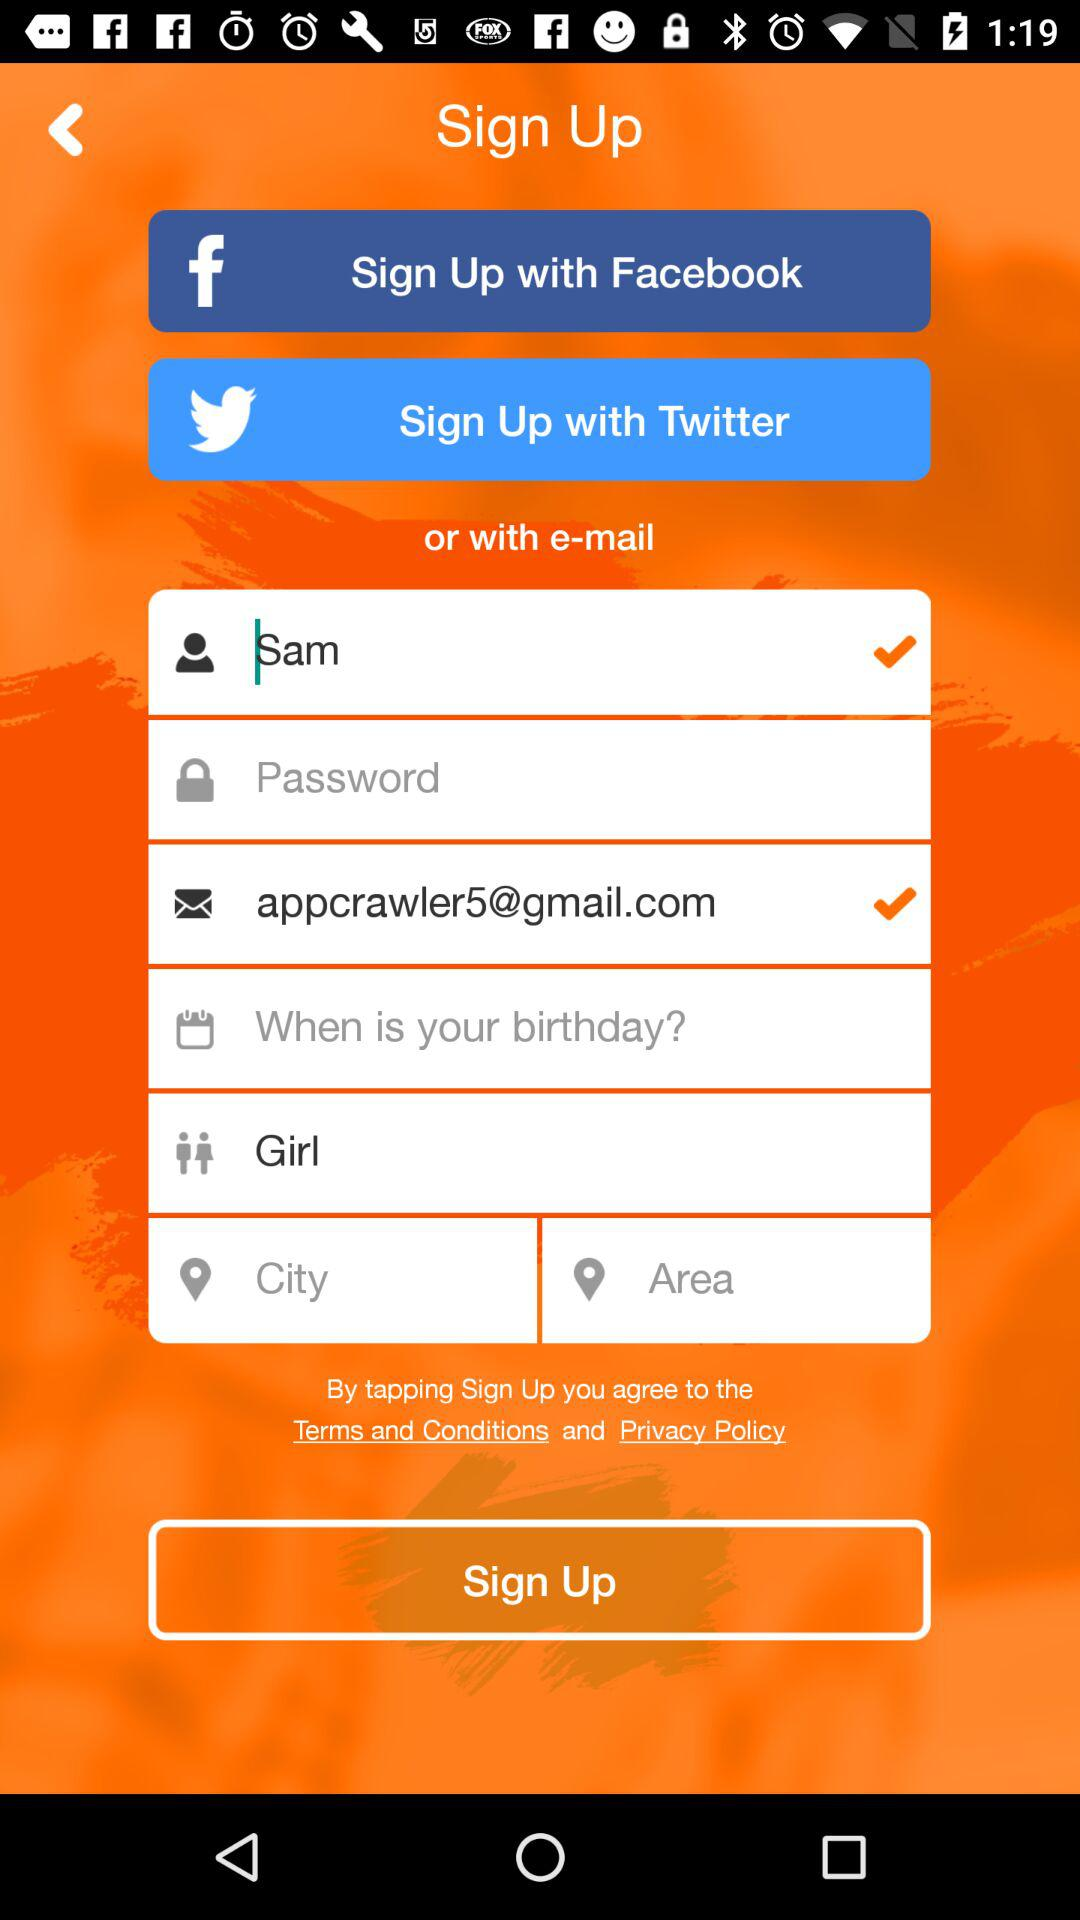What is the email address? The email address is appcrawler5@gmail.com. 